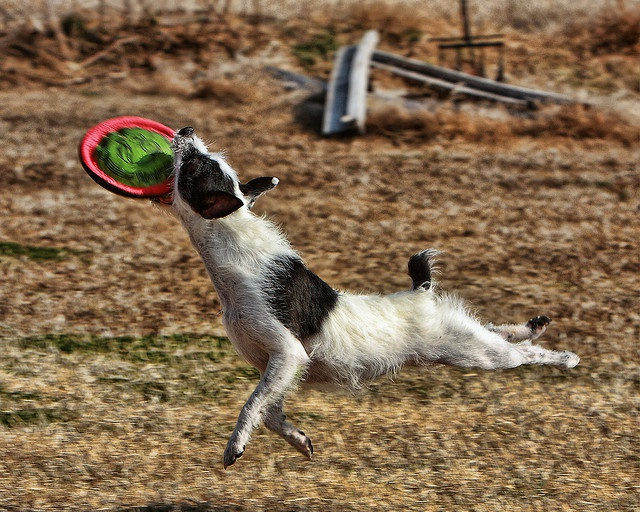Describe the objects in this image and their specific colors. I can see dog in tan, black, ivory, gray, and darkgray tones and frisbee in tan, black, darkgreen, and salmon tones in this image. 